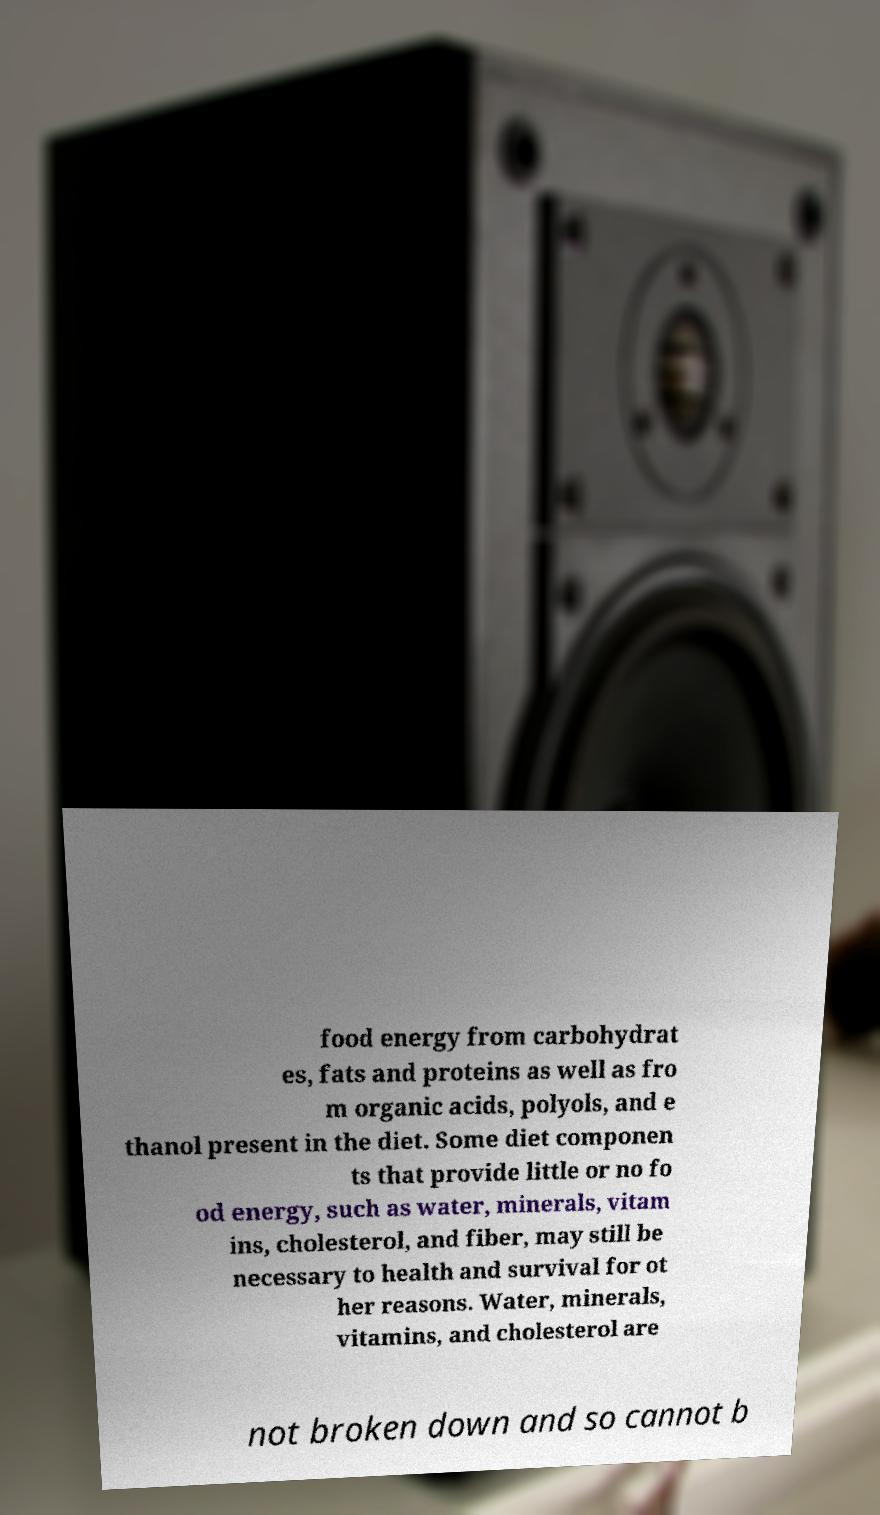What messages or text are displayed in this image? I need them in a readable, typed format. food energy from carbohydrat es, fats and proteins as well as fro m organic acids, polyols, and e thanol present in the diet. Some diet componen ts that provide little or no fo od energy, such as water, minerals, vitam ins, cholesterol, and fiber, may still be necessary to health and survival for ot her reasons. Water, minerals, vitamins, and cholesterol are not broken down and so cannot b 